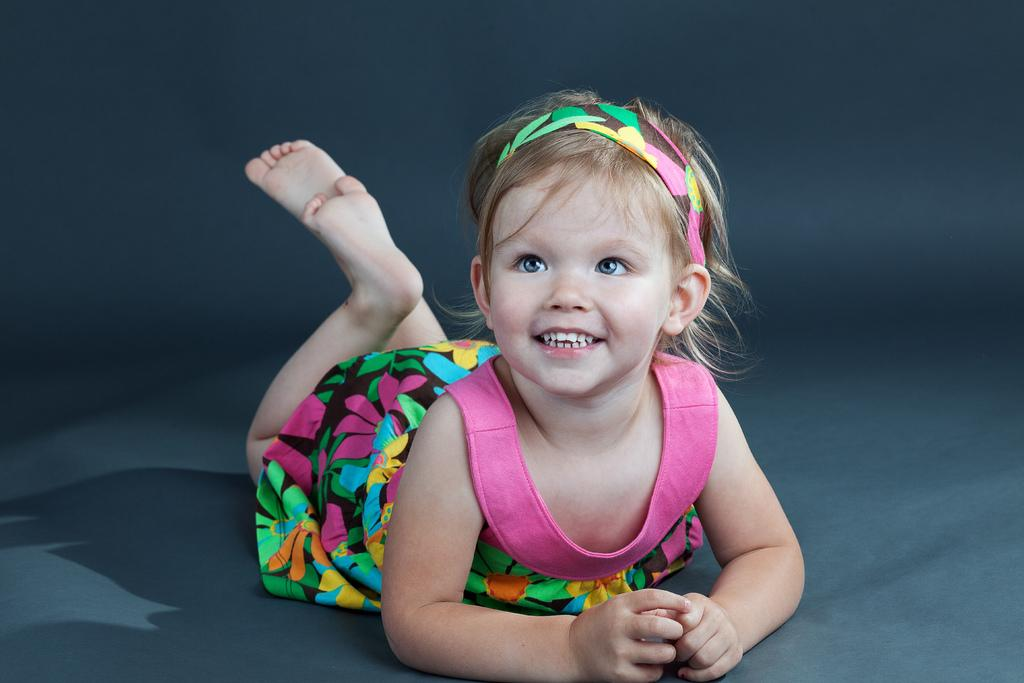What is the main subject of the image? There is a baby lying in the image. Can you describe the background of the image? The background of the image is dark. What type of coach can be seen in the image? There is no coach present in the image; it features a baby lying down with a dark background. What time of day is depicted in the image? The time of day cannot be determined from the image, as there is no reference to lighting or time-related elements. 